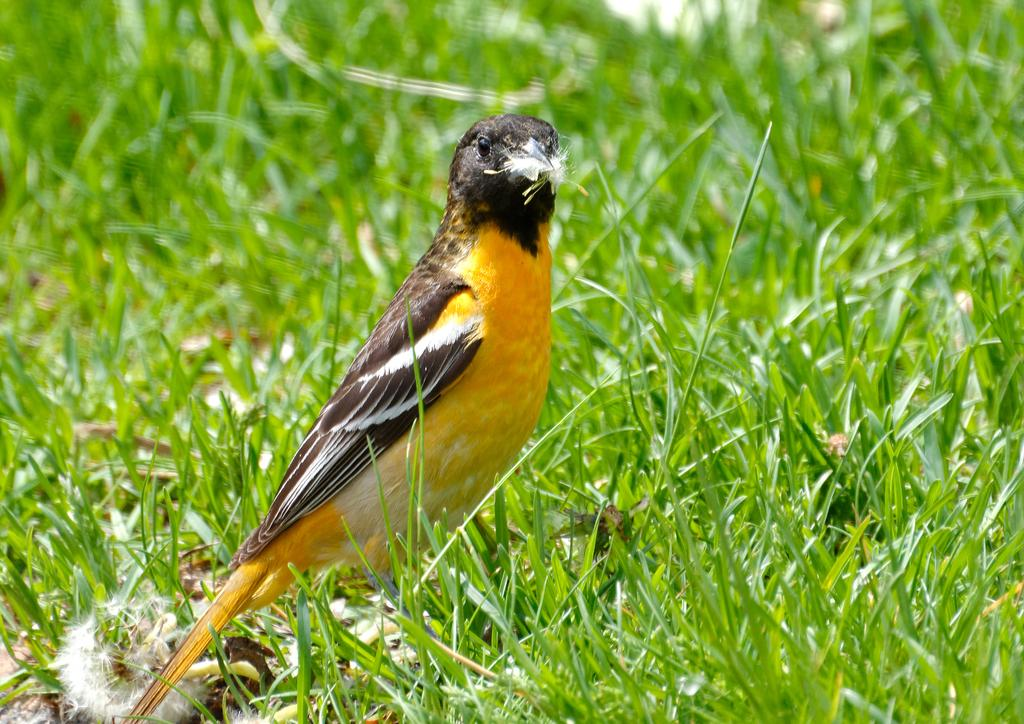What type of animal is on the ground in the image? There is a bird on the ground in the image. What is the surface on which the bird is standing? There are grasses on the ground in the image. How does the manager help the bird in the image? There is no manager present in the image, and therefore no assistance can be provided to the bird. 